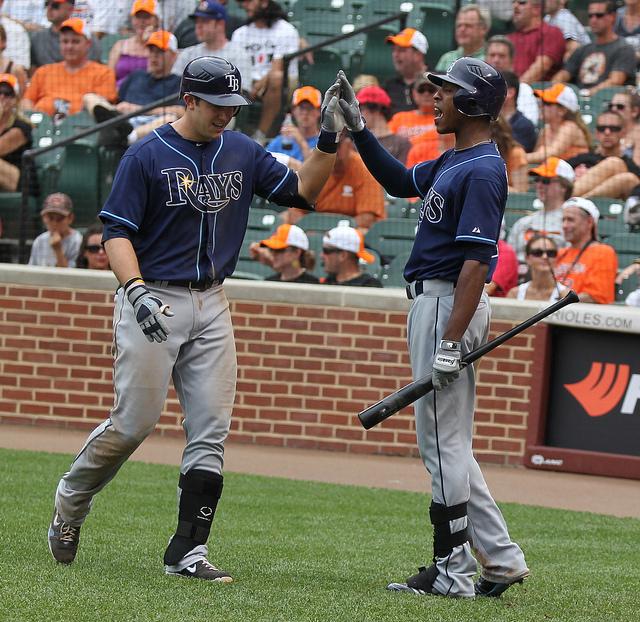What team is shown playing?
Give a very brief answer. Rays. Is someone in this scene drying his face with a towel?
Give a very brief answer. No. What is the color the crowd is wearing to support their team?
Answer briefly. Orange. Is this in the US?
Concise answer only. Yes. What team are these players on?
Write a very short answer. Rays. Do these two men play for the same team?
Keep it brief. Yes. Which team is at bat?
Answer briefly. Rays. What team does the man at bat play for?
Quick response, please. Rays. What hobby is this?
Short answer required. Baseball. Is the batter going to run to first base?
Quick response, please. No. How many people in the shot?
Give a very brief answer. 20. Where are the spectators?
Concise answer only. Stands. Is there an umpire?
Be succinct. No. What bank name can be seen?
Answer briefly. None. Is someone wearing orange?
Be succinct. Yes. 